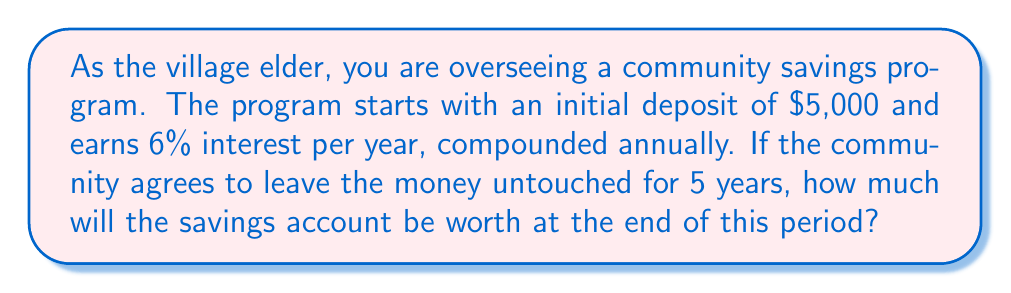Give your solution to this math problem. To solve this problem, we'll use the compound interest formula:

$$A = P(1 + r)^n$$

Where:
$A$ = Final amount
$P$ = Principal (initial deposit)
$r$ = Annual interest rate (as a decimal)
$n$ = Number of years

Given:
$P = $5,000$
$r = 6\% = 0.06$
$n = 5$ years

Let's substitute these values into the formula:

$$A = 5000(1 + 0.06)^5$$

Now, let's solve step by step:

1) First, calculate $(1 + 0.06)^5$:
   $$(1.06)^5 = 1.3382256$$

2) Multiply this result by the principal:
   $$5000 \times 1.3382256 = 6691.128$$

3) Round to the nearest cent:
   $$6691.13$$

Therefore, after 5 years, the community savings account will be worth $6,691.13.
Answer: $6,691.13 